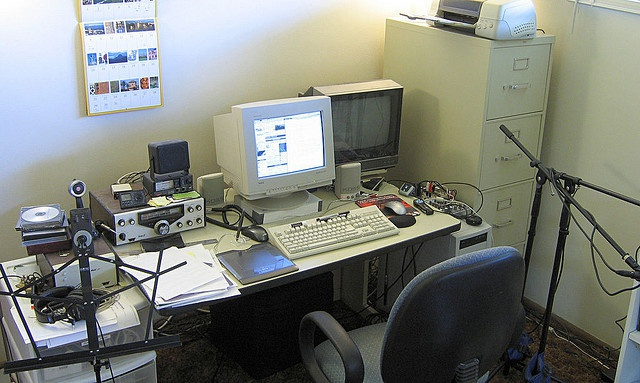Describe the objects in this image and their specific colors. I can see chair in white, black, gray, and darkblue tones, tv in white, darkgray, and gray tones, tv in white, gray, black, beige, and darkgreen tones, keyboard in white, darkgray, beige, and gray tones, and book in white, gray, and darkgray tones in this image. 